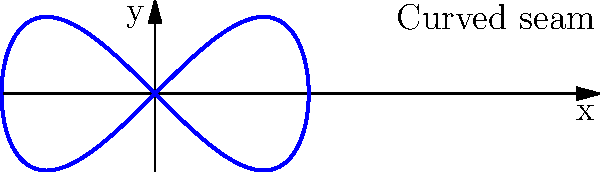In designing a form-fitting garment, you want to create a curved seam that follows a parametric equation. The curve is defined by the equations $x = \cos(t)$ and $y = \frac{1}{2}\sin(2t)$, where $t$ is the parameter. What is the maximum y-coordinate reached by this curve, and at what t-value does this occur? To find the maximum y-coordinate and its corresponding t-value, we can follow these steps:

1) The y-coordinate is given by the equation $y = \frac{1}{2}\sin(2t)$.

2) To find the maximum value, we need to find where the derivative of y with respect to t equals zero:

   $\frac{dy}{dt} = \frac{1}{2} \cdot 2 \cos(2t) = \cos(2t)$

3) Set this equal to zero:

   $\cos(2t) = 0$

4) Solve for t:

   $2t = \frac{\pi}{2}$ or $2t = \frac{3\pi}{2}$
   $t = \frac{\pi}{4}$ or $t = \frac{3\pi}{4}$

5) To determine which gives the maximum (rather than minimum), we can check the second derivative or simply evaluate y at both points:

   At $t = \frac{\pi}{4}$: $y = \frac{1}{2}\sin(2 \cdot \frac{\pi}{4}) = \frac{1}{2}\sin(\frac{\pi}{2}) = \frac{1}{2}$
   At $t = \frac{3\pi}{4}$: $y = \frac{1}{2}\sin(2 \cdot \frac{3\pi}{4}) = \frac{1}{2}\sin(\frac{3\pi}{2}) = -\frac{1}{2}$

6) Therefore, the maximum y-coordinate is $\frac{1}{2}$, occurring at $t = \frac{\pi}{4}$.
Answer: Maximum y-coordinate: $\frac{1}{2}$, occurring at $t = \frac{\pi}{4}$ 